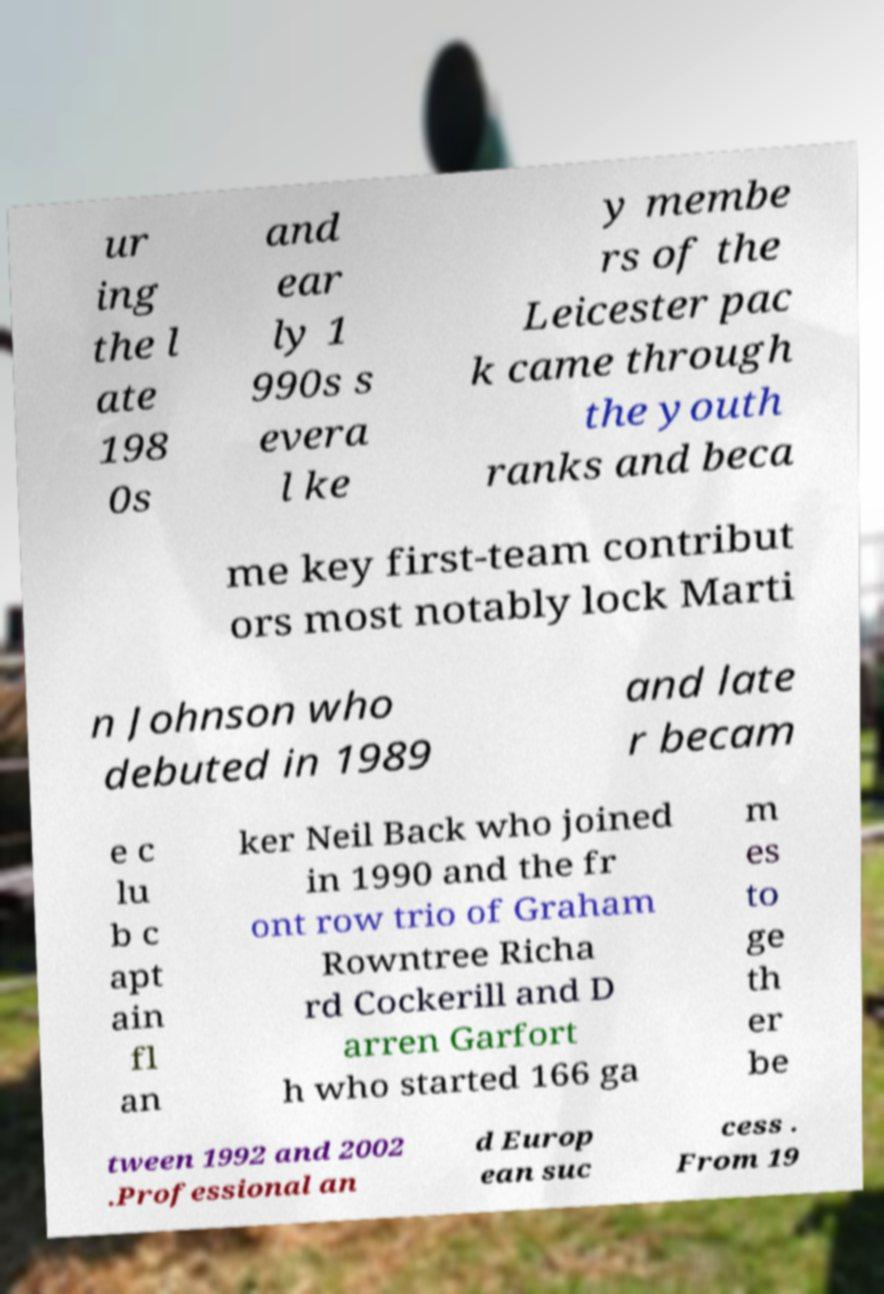Can you accurately transcribe the text from the provided image for me? ur ing the l ate 198 0s and ear ly 1 990s s evera l ke y membe rs of the Leicester pac k came through the youth ranks and beca me key first-team contribut ors most notably lock Marti n Johnson who debuted in 1989 and late r becam e c lu b c apt ain fl an ker Neil Back who joined in 1990 and the fr ont row trio of Graham Rowntree Richa rd Cockerill and D arren Garfort h who started 166 ga m es to ge th er be tween 1992 and 2002 .Professional an d Europ ean suc cess . From 19 